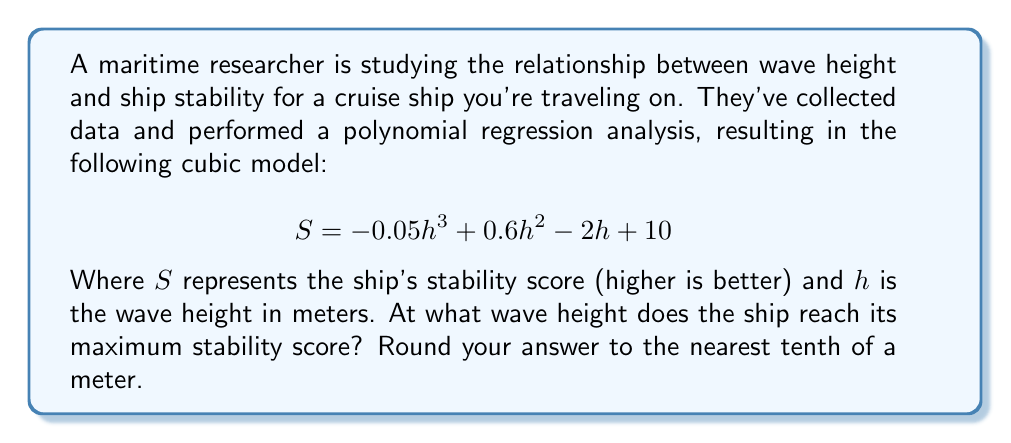Provide a solution to this math problem. To find the wave height at which the ship reaches its maximum stability score, we need to find the maximum point of the polynomial function. This can be done by following these steps:

1) First, we need to find the derivative of the function:
   $$ \frac{dS}{dh} = -0.15h^2 + 1.2h - 2 $$

2) To find the maximum point, we set the derivative equal to zero and solve for h:
   $$ -0.15h^2 + 1.2h - 2 = 0 $$

3) This is a quadratic equation. We can solve it using the quadratic formula:
   $$ h = \frac{-b \pm \sqrt{b^2 - 4ac}}{2a} $$
   Where $a = -0.15$, $b = 1.2$, and $c = -2$

4) Plugging in these values:
   $$ h = \frac{-1.2 \pm \sqrt{1.2^2 - 4(-0.15)(-2)}}{2(-0.15)} $$
   $$ = \frac{-1.2 \pm \sqrt{1.44 - 1.2}}{-0.3} $$
   $$ = \frac{-1.2 \pm \sqrt{0.24}}{-0.3} $$
   $$ = \frac{-1.2 \pm 0.4899}{-0.3} $$

5) This gives us two solutions:
   $$ h_1 = \frac{-1.2 + 0.4899}{-0.3} \approx 2.3667 $$
   $$ h_2 = \frac{-1.2 - 0.4899}{-0.3} \approx 5.6333 $$

6) To determine which of these is the maximum point, we can check the second derivative:
   $$ \frac{d^2S}{dh^2} = -0.3h + 1.2 $$

7) At $h = 2.3667$, the second derivative is negative, indicating a maximum point.

8) Rounding to the nearest tenth:
   $$ 2.3667 \approx 2.4 $$

Therefore, the ship reaches its maximum stability score at a wave height of approximately 2.4 meters.
Answer: 2.4 meters 